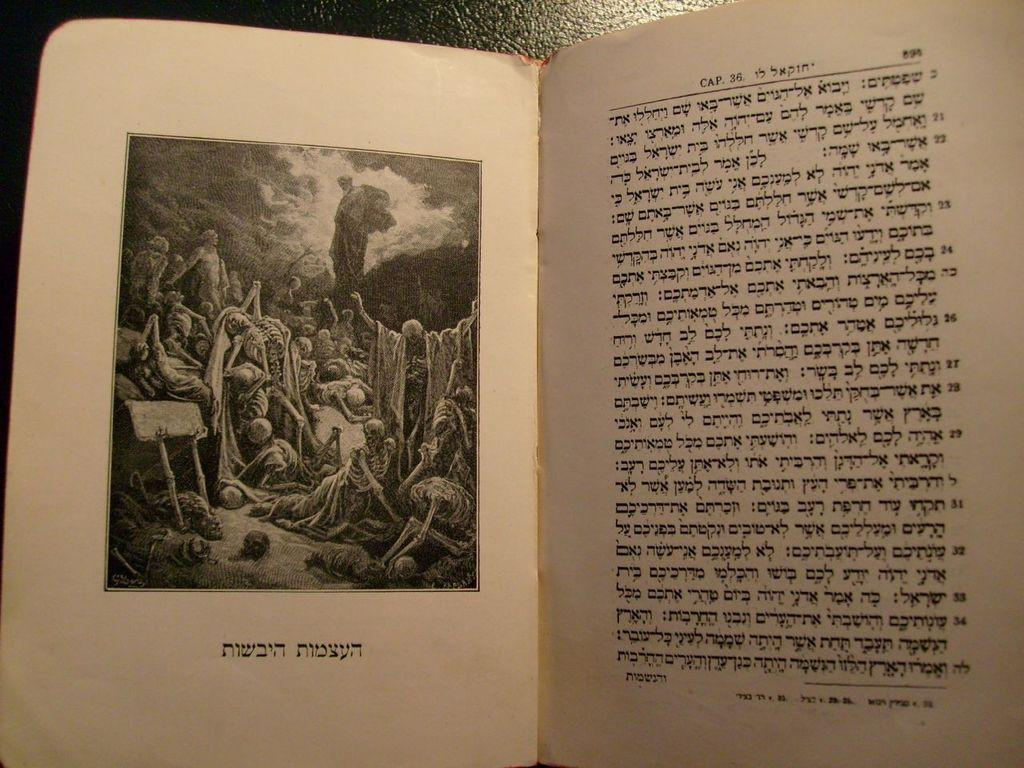Provide a one-sentence caption for the provided image. A book is open to a section titled Cap. 36. 